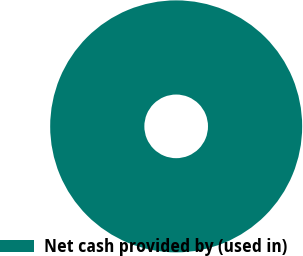Convert chart. <chart><loc_0><loc_0><loc_500><loc_500><pie_chart><fcel>Net cash provided by (used in)<nl><fcel>100.0%<nl></chart> 